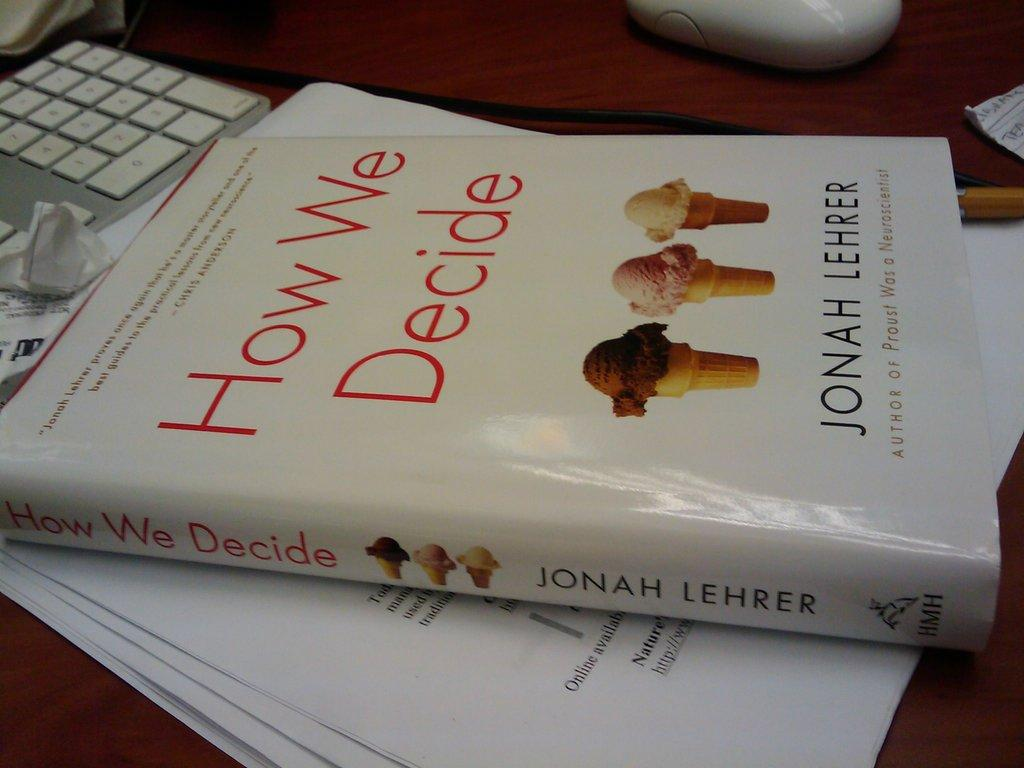What object related to reading can be seen in the image? There is a book in the image. What other items related to work or study can be seen in the image? There are papers and a keyboard visible in the image. What device is used for input in the image? There is a mouse in the image. What connects the mouse to the keyboard in the image? There is a wire in the image. What is the color of the table in the image? The table in the image is brown in color. What type of circle is present in the image? There is no circle present in the image. What kind of cast can be seen in the image? There is no cast present in the image. 